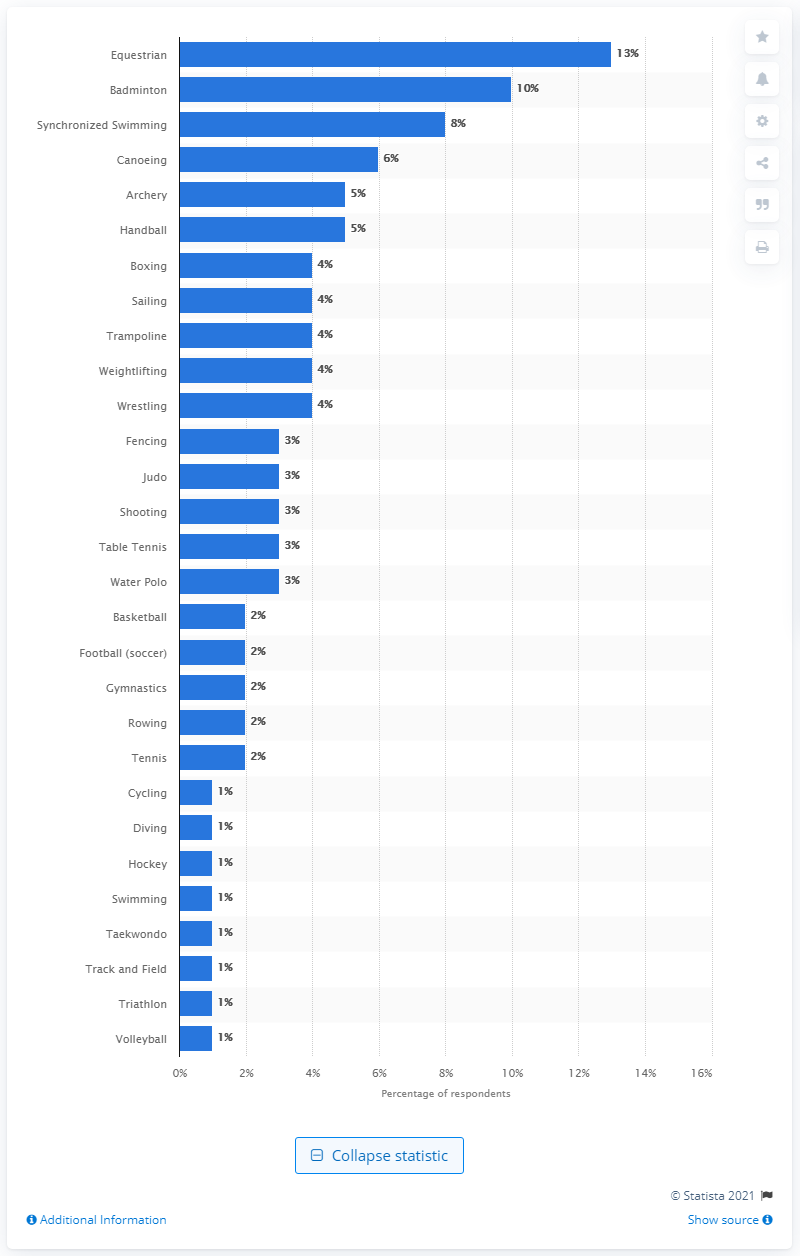Indicate a few pertinent items in this graphic. In 2012, it was announced that badminton was the least favored sport among Americans. 